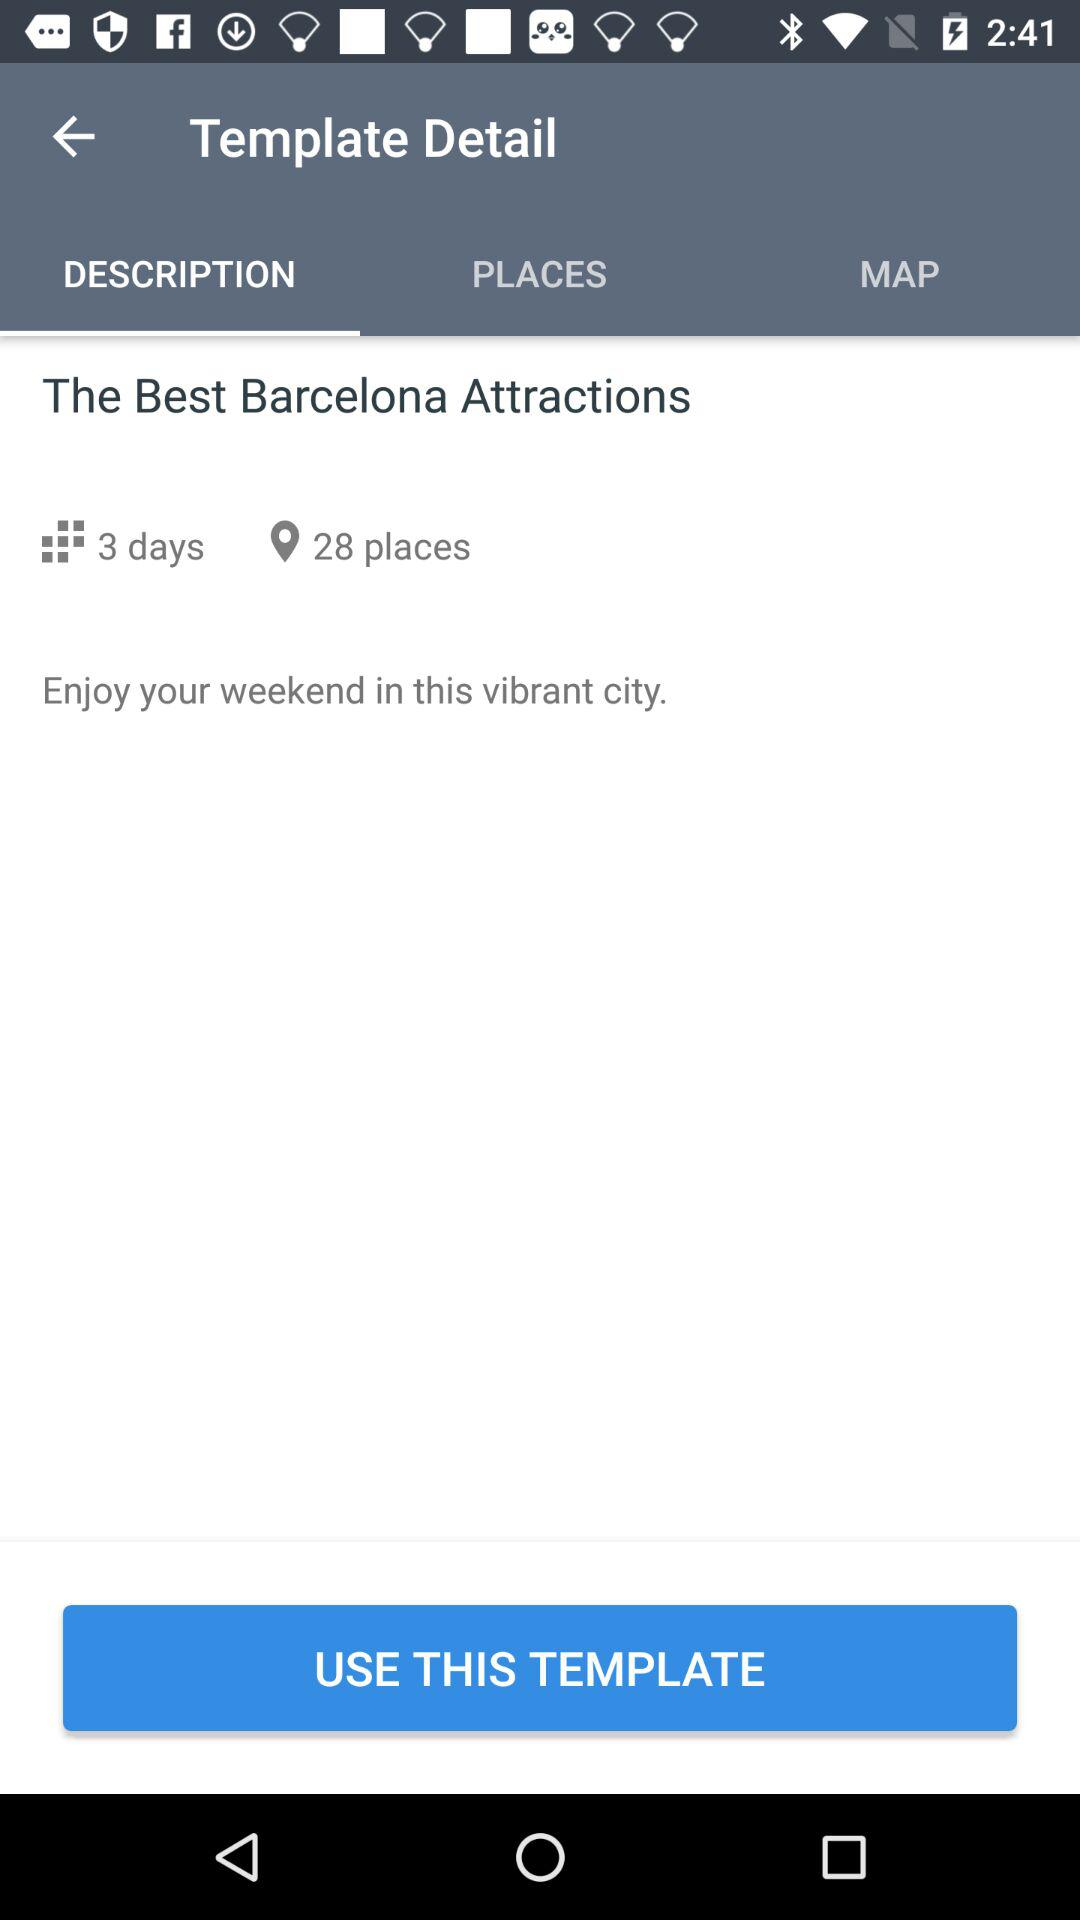How many days are in the itinerary?
Answer the question using a single word or phrase. 3 